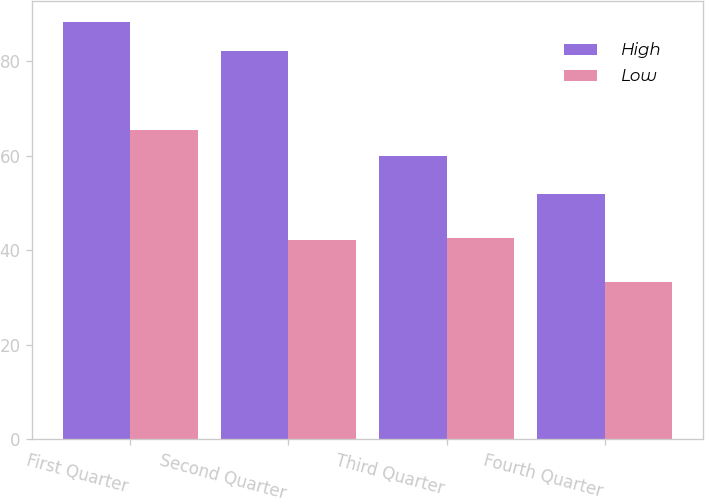Convert chart. <chart><loc_0><loc_0><loc_500><loc_500><stacked_bar_chart><ecel><fcel>First Quarter<fcel>Second Quarter<fcel>Third Quarter<fcel>Fourth Quarter<nl><fcel>High<fcel>88.35<fcel>82.25<fcel>60<fcel>51.95<nl><fcel>Low<fcel>65.44<fcel>42.24<fcel>42.67<fcel>33.3<nl></chart> 